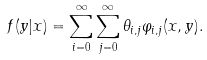Convert formula to latex. <formula><loc_0><loc_0><loc_500><loc_500>f ( y | x ) = \sum _ { i = 0 } ^ { \infty } \sum _ { j = 0 } ^ { \infty } \theta _ { i , j } \varphi _ { i , j } ( x , y ) .</formula> 